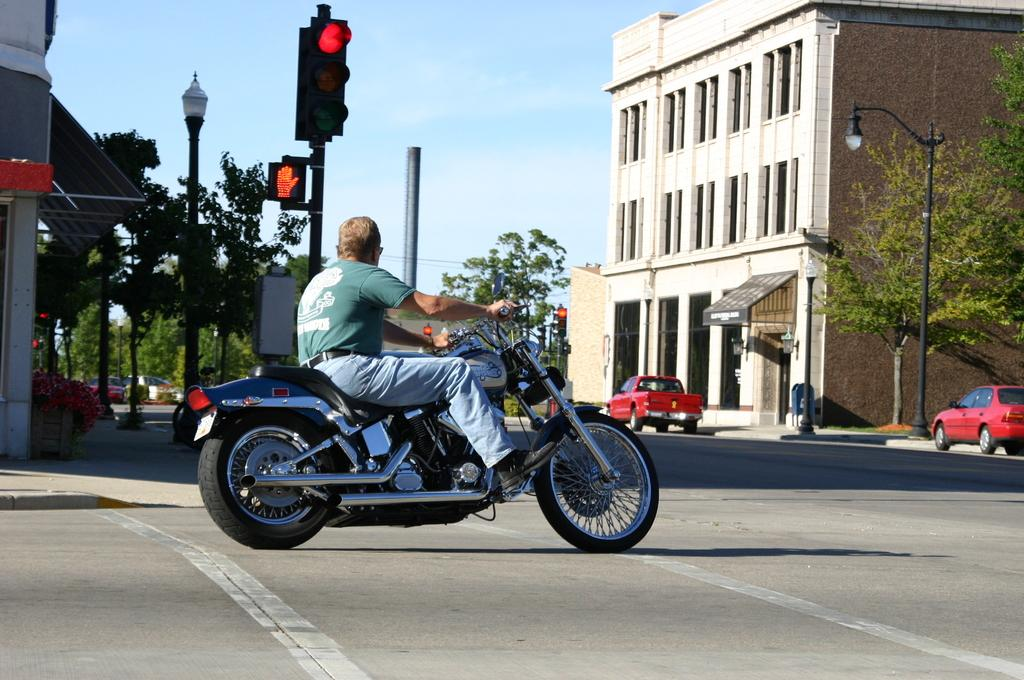What is the man in the image doing? The man is riding a motorcycle in the image. What can be seen in the background of the image? There are buildings and trees visible in the image. Are there any vehicles parked in the image? Yes, two cars are parked on the road in the image. Can you see the ocean in the image? No, the ocean is not visible in the image. 